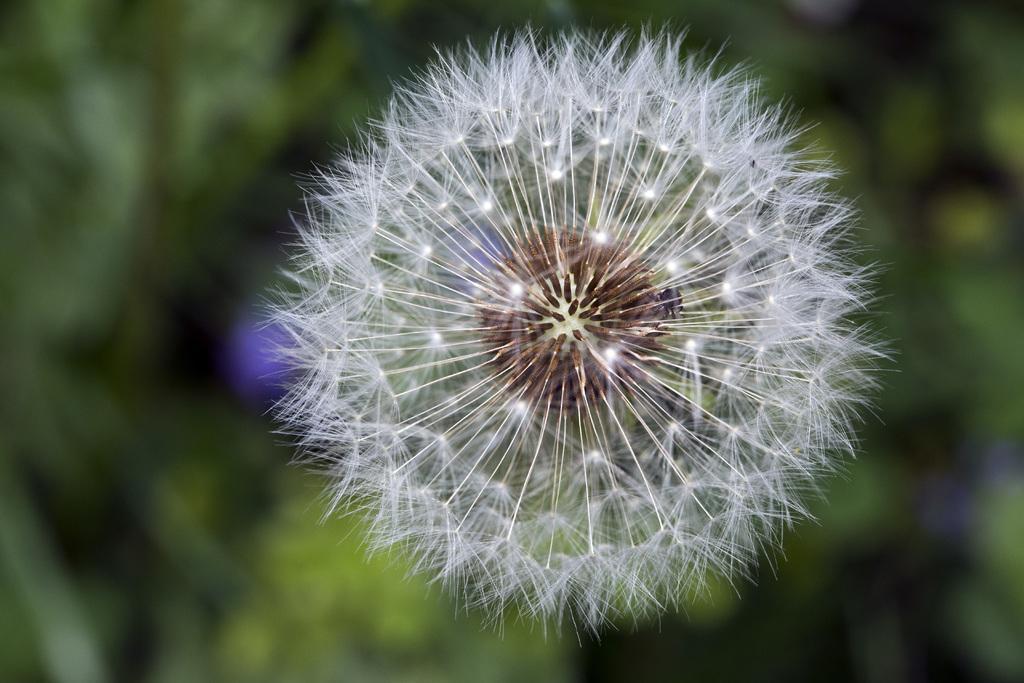How would you summarize this image in a sentence or two? In the foreground of the picture we can see a dandelion plant. In the background there is greenery. 